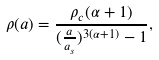Convert formula to latex. <formula><loc_0><loc_0><loc_500><loc_500>\rho ( a ) = \frac { \rho _ { c } ( \alpha + 1 ) } { ( \frac { a } { a _ { s } } ) ^ { 3 ( \alpha + 1 ) } - 1 } ,</formula> 